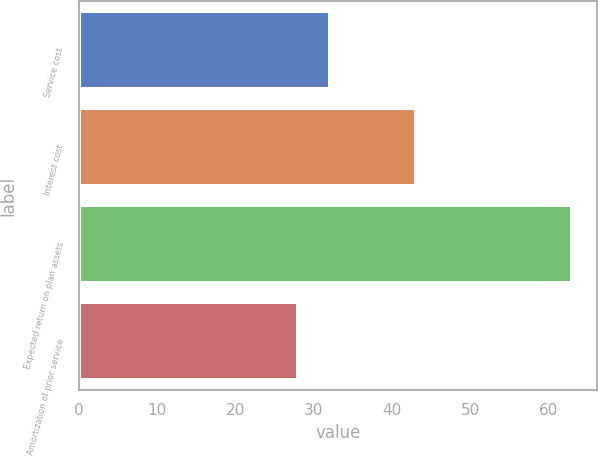<chart> <loc_0><loc_0><loc_500><loc_500><bar_chart><fcel>Service cost<fcel>Interest cost<fcel>Expected return on plan assets<fcel>Amortization of prior service<nl><fcel>32<fcel>43<fcel>63<fcel>28<nl></chart> 